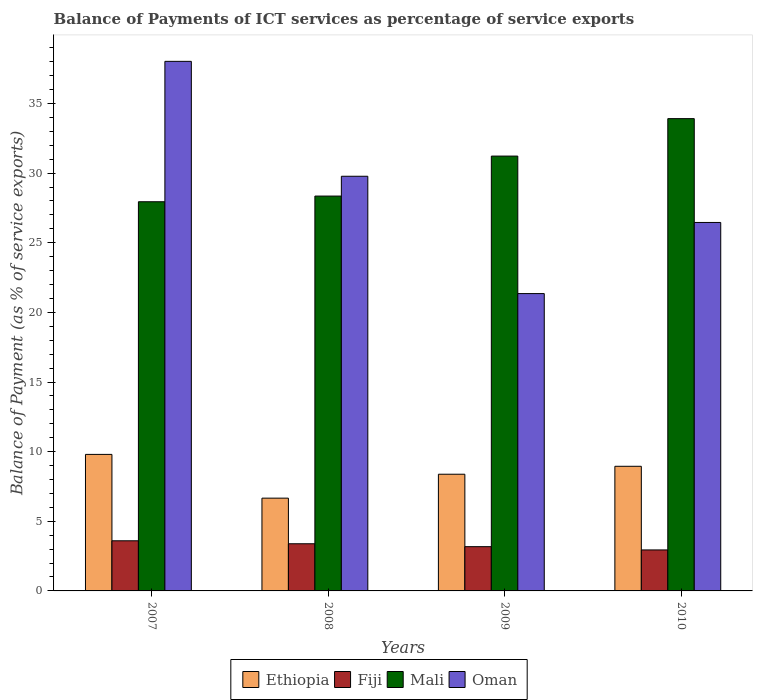How many different coloured bars are there?
Ensure brevity in your answer.  4. How many groups of bars are there?
Provide a succinct answer. 4. Are the number of bars per tick equal to the number of legend labels?
Your answer should be very brief. Yes. How many bars are there on the 2nd tick from the left?
Your answer should be very brief. 4. What is the label of the 1st group of bars from the left?
Provide a succinct answer. 2007. In how many cases, is the number of bars for a given year not equal to the number of legend labels?
Give a very brief answer. 0. What is the balance of payments of ICT services in Oman in 2008?
Make the answer very short. 29.77. Across all years, what is the maximum balance of payments of ICT services in Oman?
Provide a short and direct response. 38.02. Across all years, what is the minimum balance of payments of ICT services in Oman?
Your answer should be very brief. 21.35. In which year was the balance of payments of ICT services in Mali maximum?
Your answer should be very brief. 2010. What is the total balance of payments of ICT services in Ethiopia in the graph?
Make the answer very short. 33.79. What is the difference between the balance of payments of ICT services in Ethiopia in 2008 and that in 2010?
Your answer should be very brief. -2.29. What is the difference between the balance of payments of ICT services in Ethiopia in 2007 and the balance of payments of ICT services in Oman in 2009?
Keep it short and to the point. -11.55. What is the average balance of payments of ICT services in Ethiopia per year?
Your answer should be compact. 8.45. In the year 2009, what is the difference between the balance of payments of ICT services in Mali and balance of payments of ICT services in Oman?
Ensure brevity in your answer.  9.87. What is the ratio of the balance of payments of ICT services in Ethiopia in 2007 to that in 2010?
Keep it short and to the point. 1.1. Is the balance of payments of ICT services in Oman in 2008 less than that in 2009?
Your response must be concise. No. What is the difference between the highest and the second highest balance of payments of ICT services in Oman?
Offer a terse response. 8.25. What is the difference between the highest and the lowest balance of payments of ICT services in Ethiopia?
Make the answer very short. 3.14. In how many years, is the balance of payments of ICT services in Mali greater than the average balance of payments of ICT services in Mali taken over all years?
Your response must be concise. 2. Is it the case that in every year, the sum of the balance of payments of ICT services in Ethiopia and balance of payments of ICT services in Mali is greater than the sum of balance of payments of ICT services in Fiji and balance of payments of ICT services in Oman?
Your answer should be compact. No. What does the 2nd bar from the left in 2007 represents?
Your answer should be very brief. Fiji. What does the 1st bar from the right in 2007 represents?
Ensure brevity in your answer.  Oman. Is it the case that in every year, the sum of the balance of payments of ICT services in Fiji and balance of payments of ICT services in Oman is greater than the balance of payments of ICT services in Ethiopia?
Your response must be concise. Yes. Are all the bars in the graph horizontal?
Ensure brevity in your answer.  No. How many years are there in the graph?
Keep it short and to the point. 4. How many legend labels are there?
Give a very brief answer. 4. How are the legend labels stacked?
Keep it short and to the point. Horizontal. What is the title of the graph?
Your answer should be compact. Balance of Payments of ICT services as percentage of service exports. What is the label or title of the X-axis?
Keep it short and to the point. Years. What is the label or title of the Y-axis?
Your response must be concise. Balance of Payment (as % of service exports). What is the Balance of Payment (as % of service exports) of Ethiopia in 2007?
Your response must be concise. 9.8. What is the Balance of Payment (as % of service exports) of Fiji in 2007?
Make the answer very short. 3.6. What is the Balance of Payment (as % of service exports) of Mali in 2007?
Ensure brevity in your answer.  27.94. What is the Balance of Payment (as % of service exports) in Oman in 2007?
Ensure brevity in your answer.  38.02. What is the Balance of Payment (as % of service exports) in Ethiopia in 2008?
Your response must be concise. 6.66. What is the Balance of Payment (as % of service exports) in Fiji in 2008?
Your response must be concise. 3.39. What is the Balance of Payment (as % of service exports) of Mali in 2008?
Your response must be concise. 28.35. What is the Balance of Payment (as % of service exports) of Oman in 2008?
Make the answer very short. 29.77. What is the Balance of Payment (as % of service exports) in Ethiopia in 2009?
Keep it short and to the point. 8.38. What is the Balance of Payment (as % of service exports) of Fiji in 2009?
Give a very brief answer. 3.18. What is the Balance of Payment (as % of service exports) of Mali in 2009?
Offer a very short reply. 31.22. What is the Balance of Payment (as % of service exports) in Oman in 2009?
Your answer should be compact. 21.35. What is the Balance of Payment (as % of service exports) of Ethiopia in 2010?
Offer a terse response. 8.95. What is the Balance of Payment (as % of service exports) of Fiji in 2010?
Ensure brevity in your answer.  2.94. What is the Balance of Payment (as % of service exports) in Mali in 2010?
Make the answer very short. 33.91. What is the Balance of Payment (as % of service exports) in Oman in 2010?
Keep it short and to the point. 26.45. Across all years, what is the maximum Balance of Payment (as % of service exports) of Ethiopia?
Provide a succinct answer. 9.8. Across all years, what is the maximum Balance of Payment (as % of service exports) in Fiji?
Your answer should be compact. 3.6. Across all years, what is the maximum Balance of Payment (as % of service exports) in Mali?
Your answer should be very brief. 33.91. Across all years, what is the maximum Balance of Payment (as % of service exports) of Oman?
Provide a short and direct response. 38.02. Across all years, what is the minimum Balance of Payment (as % of service exports) of Ethiopia?
Provide a succinct answer. 6.66. Across all years, what is the minimum Balance of Payment (as % of service exports) of Fiji?
Ensure brevity in your answer.  2.94. Across all years, what is the minimum Balance of Payment (as % of service exports) of Mali?
Ensure brevity in your answer.  27.94. Across all years, what is the minimum Balance of Payment (as % of service exports) in Oman?
Provide a short and direct response. 21.35. What is the total Balance of Payment (as % of service exports) in Ethiopia in the graph?
Your answer should be compact. 33.79. What is the total Balance of Payment (as % of service exports) in Fiji in the graph?
Offer a terse response. 13.1. What is the total Balance of Payment (as % of service exports) of Mali in the graph?
Offer a terse response. 121.42. What is the total Balance of Payment (as % of service exports) in Oman in the graph?
Ensure brevity in your answer.  115.6. What is the difference between the Balance of Payment (as % of service exports) of Ethiopia in 2007 and that in 2008?
Provide a short and direct response. 3.14. What is the difference between the Balance of Payment (as % of service exports) in Fiji in 2007 and that in 2008?
Your answer should be compact. 0.21. What is the difference between the Balance of Payment (as % of service exports) of Mali in 2007 and that in 2008?
Keep it short and to the point. -0.41. What is the difference between the Balance of Payment (as % of service exports) in Oman in 2007 and that in 2008?
Your answer should be very brief. 8.25. What is the difference between the Balance of Payment (as % of service exports) of Ethiopia in 2007 and that in 2009?
Your response must be concise. 1.42. What is the difference between the Balance of Payment (as % of service exports) of Fiji in 2007 and that in 2009?
Your answer should be very brief. 0.42. What is the difference between the Balance of Payment (as % of service exports) in Mali in 2007 and that in 2009?
Your response must be concise. -3.28. What is the difference between the Balance of Payment (as % of service exports) of Oman in 2007 and that in 2009?
Provide a succinct answer. 16.67. What is the difference between the Balance of Payment (as % of service exports) of Ethiopia in 2007 and that in 2010?
Provide a succinct answer. 0.85. What is the difference between the Balance of Payment (as % of service exports) of Fiji in 2007 and that in 2010?
Give a very brief answer. 0.66. What is the difference between the Balance of Payment (as % of service exports) of Mali in 2007 and that in 2010?
Offer a very short reply. -5.97. What is the difference between the Balance of Payment (as % of service exports) of Oman in 2007 and that in 2010?
Your answer should be compact. 11.57. What is the difference between the Balance of Payment (as % of service exports) in Ethiopia in 2008 and that in 2009?
Offer a very short reply. -1.72. What is the difference between the Balance of Payment (as % of service exports) of Fiji in 2008 and that in 2009?
Provide a short and direct response. 0.21. What is the difference between the Balance of Payment (as % of service exports) in Mali in 2008 and that in 2009?
Provide a succinct answer. -2.87. What is the difference between the Balance of Payment (as % of service exports) of Oman in 2008 and that in 2009?
Give a very brief answer. 8.42. What is the difference between the Balance of Payment (as % of service exports) of Ethiopia in 2008 and that in 2010?
Ensure brevity in your answer.  -2.29. What is the difference between the Balance of Payment (as % of service exports) in Fiji in 2008 and that in 2010?
Provide a short and direct response. 0.44. What is the difference between the Balance of Payment (as % of service exports) in Mali in 2008 and that in 2010?
Give a very brief answer. -5.56. What is the difference between the Balance of Payment (as % of service exports) of Oman in 2008 and that in 2010?
Provide a short and direct response. 3.32. What is the difference between the Balance of Payment (as % of service exports) in Ethiopia in 2009 and that in 2010?
Offer a very short reply. -0.57. What is the difference between the Balance of Payment (as % of service exports) of Fiji in 2009 and that in 2010?
Make the answer very short. 0.23. What is the difference between the Balance of Payment (as % of service exports) of Mali in 2009 and that in 2010?
Provide a short and direct response. -2.69. What is the difference between the Balance of Payment (as % of service exports) of Oman in 2009 and that in 2010?
Your response must be concise. -5.11. What is the difference between the Balance of Payment (as % of service exports) in Ethiopia in 2007 and the Balance of Payment (as % of service exports) in Fiji in 2008?
Ensure brevity in your answer.  6.42. What is the difference between the Balance of Payment (as % of service exports) of Ethiopia in 2007 and the Balance of Payment (as % of service exports) of Mali in 2008?
Give a very brief answer. -18.55. What is the difference between the Balance of Payment (as % of service exports) of Ethiopia in 2007 and the Balance of Payment (as % of service exports) of Oman in 2008?
Your answer should be very brief. -19.97. What is the difference between the Balance of Payment (as % of service exports) of Fiji in 2007 and the Balance of Payment (as % of service exports) of Mali in 2008?
Offer a terse response. -24.75. What is the difference between the Balance of Payment (as % of service exports) of Fiji in 2007 and the Balance of Payment (as % of service exports) of Oman in 2008?
Give a very brief answer. -26.17. What is the difference between the Balance of Payment (as % of service exports) of Mali in 2007 and the Balance of Payment (as % of service exports) of Oman in 2008?
Your response must be concise. -1.83. What is the difference between the Balance of Payment (as % of service exports) in Ethiopia in 2007 and the Balance of Payment (as % of service exports) in Fiji in 2009?
Ensure brevity in your answer.  6.62. What is the difference between the Balance of Payment (as % of service exports) of Ethiopia in 2007 and the Balance of Payment (as % of service exports) of Mali in 2009?
Your answer should be compact. -21.42. What is the difference between the Balance of Payment (as % of service exports) of Ethiopia in 2007 and the Balance of Payment (as % of service exports) of Oman in 2009?
Offer a very short reply. -11.55. What is the difference between the Balance of Payment (as % of service exports) in Fiji in 2007 and the Balance of Payment (as % of service exports) in Mali in 2009?
Make the answer very short. -27.62. What is the difference between the Balance of Payment (as % of service exports) of Fiji in 2007 and the Balance of Payment (as % of service exports) of Oman in 2009?
Offer a terse response. -17.75. What is the difference between the Balance of Payment (as % of service exports) in Mali in 2007 and the Balance of Payment (as % of service exports) in Oman in 2009?
Your response must be concise. 6.59. What is the difference between the Balance of Payment (as % of service exports) in Ethiopia in 2007 and the Balance of Payment (as % of service exports) in Fiji in 2010?
Ensure brevity in your answer.  6.86. What is the difference between the Balance of Payment (as % of service exports) in Ethiopia in 2007 and the Balance of Payment (as % of service exports) in Mali in 2010?
Keep it short and to the point. -24.11. What is the difference between the Balance of Payment (as % of service exports) in Ethiopia in 2007 and the Balance of Payment (as % of service exports) in Oman in 2010?
Your response must be concise. -16.65. What is the difference between the Balance of Payment (as % of service exports) of Fiji in 2007 and the Balance of Payment (as % of service exports) of Mali in 2010?
Your response must be concise. -30.31. What is the difference between the Balance of Payment (as % of service exports) in Fiji in 2007 and the Balance of Payment (as % of service exports) in Oman in 2010?
Provide a short and direct response. -22.86. What is the difference between the Balance of Payment (as % of service exports) of Mali in 2007 and the Balance of Payment (as % of service exports) of Oman in 2010?
Keep it short and to the point. 1.49. What is the difference between the Balance of Payment (as % of service exports) in Ethiopia in 2008 and the Balance of Payment (as % of service exports) in Fiji in 2009?
Keep it short and to the point. 3.48. What is the difference between the Balance of Payment (as % of service exports) of Ethiopia in 2008 and the Balance of Payment (as % of service exports) of Mali in 2009?
Keep it short and to the point. -24.56. What is the difference between the Balance of Payment (as % of service exports) in Ethiopia in 2008 and the Balance of Payment (as % of service exports) in Oman in 2009?
Provide a succinct answer. -14.69. What is the difference between the Balance of Payment (as % of service exports) in Fiji in 2008 and the Balance of Payment (as % of service exports) in Mali in 2009?
Provide a short and direct response. -27.83. What is the difference between the Balance of Payment (as % of service exports) in Fiji in 2008 and the Balance of Payment (as % of service exports) in Oman in 2009?
Keep it short and to the point. -17.96. What is the difference between the Balance of Payment (as % of service exports) in Mali in 2008 and the Balance of Payment (as % of service exports) in Oman in 2009?
Give a very brief answer. 7. What is the difference between the Balance of Payment (as % of service exports) of Ethiopia in 2008 and the Balance of Payment (as % of service exports) of Fiji in 2010?
Make the answer very short. 3.72. What is the difference between the Balance of Payment (as % of service exports) of Ethiopia in 2008 and the Balance of Payment (as % of service exports) of Mali in 2010?
Provide a short and direct response. -27.25. What is the difference between the Balance of Payment (as % of service exports) of Ethiopia in 2008 and the Balance of Payment (as % of service exports) of Oman in 2010?
Your response must be concise. -19.79. What is the difference between the Balance of Payment (as % of service exports) in Fiji in 2008 and the Balance of Payment (as % of service exports) in Mali in 2010?
Your answer should be compact. -30.52. What is the difference between the Balance of Payment (as % of service exports) in Fiji in 2008 and the Balance of Payment (as % of service exports) in Oman in 2010?
Make the answer very short. -23.07. What is the difference between the Balance of Payment (as % of service exports) of Mali in 2008 and the Balance of Payment (as % of service exports) of Oman in 2010?
Your answer should be very brief. 1.89. What is the difference between the Balance of Payment (as % of service exports) in Ethiopia in 2009 and the Balance of Payment (as % of service exports) in Fiji in 2010?
Your response must be concise. 5.44. What is the difference between the Balance of Payment (as % of service exports) in Ethiopia in 2009 and the Balance of Payment (as % of service exports) in Mali in 2010?
Offer a terse response. -25.53. What is the difference between the Balance of Payment (as % of service exports) of Ethiopia in 2009 and the Balance of Payment (as % of service exports) of Oman in 2010?
Offer a terse response. -18.08. What is the difference between the Balance of Payment (as % of service exports) of Fiji in 2009 and the Balance of Payment (as % of service exports) of Mali in 2010?
Keep it short and to the point. -30.73. What is the difference between the Balance of Payment (as % of service exports) in Fiji in 2009 and the Balance of Payment (as % of service exports) in Oman in 2010?
Ensure brevity in your answer.  -23.28. What is the difference between the Balance of Payment (as % of service exports) in Mali in 2009 and the Balance of Payment (as % of service exports) in Oman in 2010?
Provide a succinct answer. 4.77. What is the average Balance of Payment (as % of service exports) in Ethiopia per year?
Offer a terse response. 8.45. What is the average Balance of Payment (as % of service exports) of Fiji per year?
Ensure brevity in your answer.  3.28. What is the average Balance of Payment (as % of service exports) of Mali per year?
Provide a short and direct response. 30.35. What is the average Balance of Payment (as % of service exports) in Oman per year?
Keep it short and to the point. 28.9. In the year 2007, what is the difference between the Balance of Payment (as % of service exports) in Ethiopia and Balance of Payment (as % of service exports) in Fiji?
Offer a terse response. 6.2. In the year 2007, what is the difference between the Balance of Payment (as % of service exports) of Ethiopia and Balance of Payment (as % of service exports) of Mali?
Ensure brevity in your answer.  -18.14. In the year 2007, what is the difference between the Balance of Payment (as % of service exports) of Ethiopia and Balance of Payment (as % of service exports) of Oman?
Keep it short and to the point. -28.22. In the year 2007, what is the difference between the Balance of Payment (as % of service exports) of Fiji and Balance of Payment (as % of service exports) of Mali?
Your answer should be compact. -24.34. In the year 2007, what is the difference between the Balance of Payment (as % of service exports) in Fiji and Balance of Payment (as % of service exports) in Oman?
Offer a very short reply. -34.42. In the year 2007, what is the difference between the Balance of Payment (as % of service exports) of Mali and Balance of Payment (as % of service exports) of Oman?
Your response must be concise. -10.08. In the year 2008, what is the difference between the Balance of Payment (as % of service exports) in Ethiopia and Balance of Payment (as % of service exports) in Fiji?
Give a very brief answer. 3.27. In the year 2008, what is the difference between the Balance of Payment (as % of service exports) in Ethiopia and Balance of Payment (as % of service exports) in Mali?
Provide a short and direct response. -21.69. In the year 2008, what is the difference between the Balance of Payment (as % of service exports) in Ethiopia and Balance of Payment (as % of service exports) in Oman?
Provide a short and direct response. -23.11. In the year 2008, what is the difference between the Balance of Payment (as % of service exports) of Fiji and Balance of Payment (as % of service exports) of Mali?
Offer a terse response. -24.96. In the year 2008, what is the difference between the Balance of Payment (as % of service exports) in Fiji and Balance of Payment (as % of service exports) in Oman?
Your response must be concise. -26.39. In the year 2008, what is the difference between the Balance of Payment (as % of service exports) of Mali and Balance of Payment (as % of service exports) of Oman?
Your response must be concise. -1.42. In the year 2009, what is the difference between the Balance of Payment (as % of service exports) in Ethiopia and Balance of Payment (as % of service exports) in Fiji?
Offer a terse response. 5.2. In the year 2009, what is the difference between the Balance of Payment (as % of service exports) of Ethiopia and Balance of Payment (as % of service exports) of Mali?
Offer a terse response. -22.84. In the year 2009, what is the difference between the Balance of Payment (as % of service exports) of Ethiopia and Balance of Payment (as % of service exports) of Oman?
Provide a succinct answer. -12.97. In the year 2009, what is the difference between the Balance of Payment (as % of service exports) in Fiji and Balance of Payment (as % of service exports) in Mali?
Your answer should be compact. -28.04. In the year 2009, what is the difference between the Balance of Payment (as % of service exports) in Fiji and Balance of Payment (as % of service exports) in Oman?
Your response must be concise. -18.17. In the year 2009, what is the difference between the Balance of Payment (as % of service exports) of Mali and Balance of Payment (as % of service exports) of Oman?
Offer a very short reply. 9.87. In the year 2010, what is the difference between the Balance of Payment (as % of service exports) of Ethiopia and Balance of Payment (as % of service exports) of Fiji?
Ensure brevity in your answer.  6.01. In the year 2010, what is the difference between the Balance of Payment (as % of service exports) in Ethiopia and Balance of Payment (as % of service exports) in Mali?
Provide a short and direct response. -24.96. In the year 2010, what is the difference between the Balance of Payment (as % of service exports) of Ethiopia and Balance of Payment (as % of service exports) of Oman?
Make the answer very short. -17.51. In the year 2010, what is the difference between the Balance of Payment (as % of service exports) in Fiji and Balance of Payment (as % of service exports) in Mali?
Your response must be concise. -30.97. In the year 2010, what is the difference between the Balance of Payment (as % of service exports) in Fiji and Balance of Payment (as % of service exports) in Oman?
Provide a short and direct response. -23.51. In the year 2010, what is the difference between the Balance of Payment (as % of service exports) in Mali and Balance of Payment (as % of service exports) in Oman?
Your answer should be very brief. 7.45. What is the ratio of the Balance of Payment (as % of service exports) in Ethiopia in 2007 to that in 2008?
Keep it short and to the point. 1.47. What is the ratio of the Balance of Payment (as % of service exports) of Fiji in 2007 to that in 2008?
Provide a short and direct response. 1.06. What is the ratio of the Balance of Payment (as % of service exports) of Mali in 2007 to that in 2008?
Offer a very short reply. 0.99. What is the ratio of the Balance of Payment (as % of service exports) of Oman in 2007 to that in 2008?
Give a very brief answer. 1.28. What is the ratio of the Balance of Payment (as % of service exports) of Ethiopia in 2007 to that in 2009?
Provide a short and direct response. 1.17. What is the ratio of the Balance of Payment (as % of service exports) of Fiji in 2007 to that in 2009?
Keep it short and to the point. 1.13. What is the ratio of the Balance of Payment (as % of service exports) in Mali in 2007 to that in 2009?
Provide a succinct answer. 0.9. What is the ratio of the Balance of Payment (as % of service exports) in Oman in 2007 to that in 2009?
Ensure brevity in your answer.  1.78. What is the ratio of the Balance of Payment (as % of service exports) of Ethiopia in 2007 to that in 2010?
Your response must be concise. 1.1. What is the ratio of the Balance of Payment (as % of service exports) of Fiji in 2007 to that in 2010?
Offer a terse response. 1.22. What is the ratio of the Balance of Payment (as % of service exports) of Mali in 2007 to that in 2010?
Give a very brief answer. 0.82. What is the ratio of the Balance of Payment (as % of service exports) in Oman in 2007 to that in 2010?
Provide a short and direct response. 1.44. What is the ratio of the Balance of Payment (as % of service exports) in Ethiopia in 2008 to that in 2009?
Make the answer very short. 0.79. What is the ratio of the Balance of Payment (as % of service exports) in Fiji in 2008 to that in 2009?
Keep it short and to the point. 1.07. What is the ratio of the Balance of Payment (as % of service exports) in Mali in 2008 to that in 2009?
Your answer should be compact. 0.91. What is the ratio of the Balance of Payment (as % of service exports) of Oman in 2008 to that in 2009?
Keep it short and to the point. 1.39. What is the ratio of the Balance of Payment (as % of service exports) of Ethiopia in 2008 to that in 2010?
Provide a succinct answer. 0.74. What is the ratio of the Balance of Payment (as % of service exports) of Fiji in 2008 to that in 2010?
Offer a very short reply. 1.15. What is the ratio of the Balance of Payment (as % of service exports) of Mali in 2008 to that in 2010?
Give a very brief answer. 0.84. What is the ratio of the Balance of Payment (as % of service exports) in Oman in 2008 to that in 2010?
Your answer should be very brief. 1.13. What is the ratio of the Balance of Payment (as % of service exports) of Ethiopia in 2009 to that in 2010?
Give a very brief answer. 0.94. What is the ratio of the Balance of Payment (as % of service exports) of Fiji in 2009 to that in 2010?
Offer a very short reply. 1.08. What is the ratio of the Balance of Payment (as % of service exports) of Mali in 2009 to that in 2010?
Offer a terse response. 0.92. What is the ratio of the Balance of Payment (as % of service exports) of Oman in 2009 to that in 2010?
Keep it short and to the point. 0.81. What is the difference between the highest and the second highest Balance of Payment (as % of service exports) in Ethiopia?
Keep it short and to the point. 0.85. What is the difference between the highest and the second highest Balance of Payment (as % of service exports) of Fiji?
Offer a terse response. 0.21. What is the difference between the highest and the second highest Balance of Payment (as % of service exports) of Mali?
Your answer should be very brief. 2.69. What is the difference between the highest and the second highest Balance of Payment (as % of service exports) in Oman?
Ensure brevity in your answer.  8.25. What is the difference between the highest and the lowest Balance of Payment (as % of service exports) of Ethiopia?
Offer a very short reply. 3.14. What is the difference between the highest and the lowest Balance of Payment (as % of service exports) in Fiji?
Your answer should be very brief. 0.66. What is the difference between the highest and the lowest Balance of Payment (as % of service exports) of Mali?
Keep it short and to the point. 5.97. What is the difference between the highest and the lowest Balance of Payment (as % of service exports) of Oman?
Offer a terse response. 16.67. 